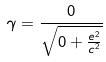Convert formula to latex. <formula><loc_0><loc_0><loc_500><loc_500>\gamma = \frac { 0 } { \sqrt { 0 + \frac { e ^ { 2 } } { c ^ { 2 } } } }</formula> 